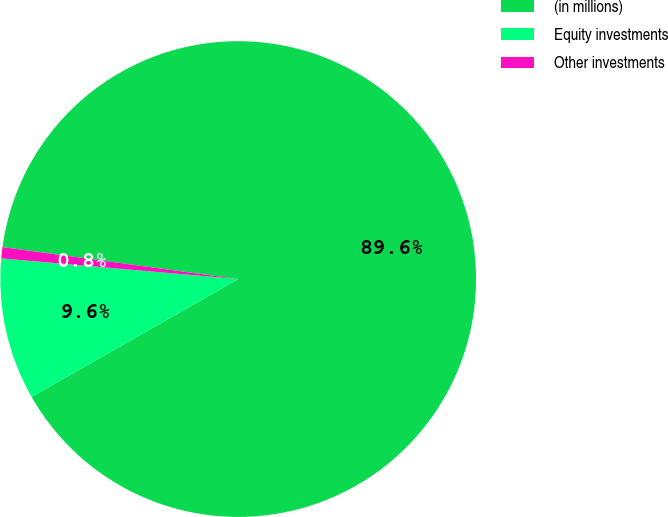Convert chart. <chart><loc_0><loc_0><loc_500><loc_500><pie_chart><fcel>(in millions)<fcel>Equity investments<fcel>Other investments<nl><fcel>89.6%<fcel>9.64%<fcel>0.76%<nl></chart> 